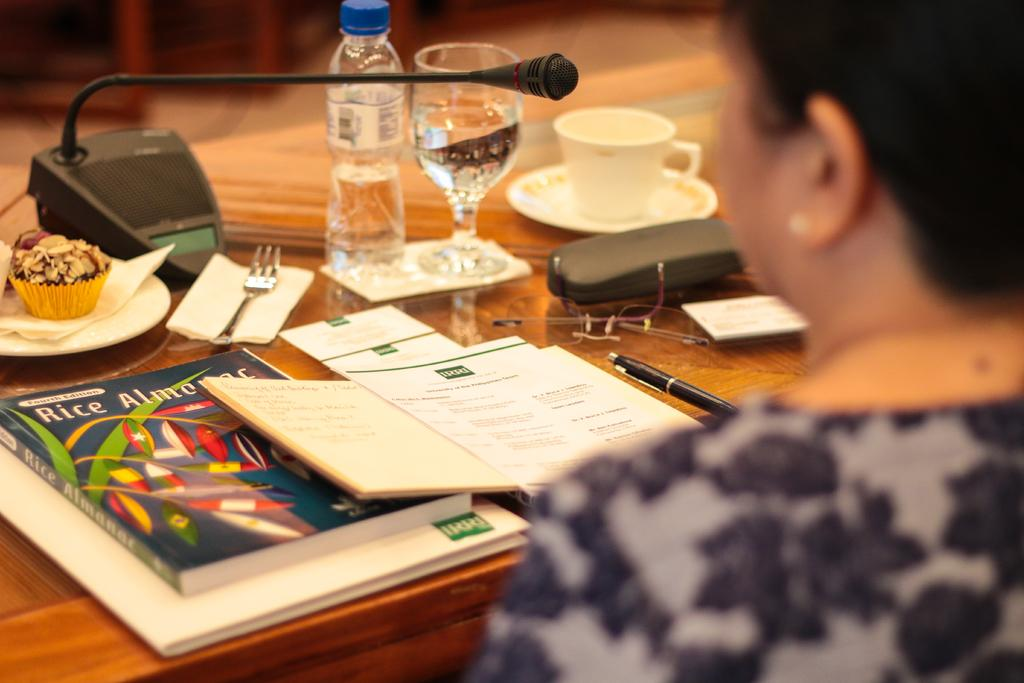Provide a one-sentence caption for the provided image. A Rice Almanac is sitting on a table with a water bottle and a cupcake. 